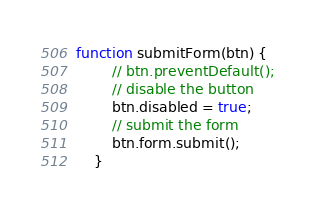Convert code to text. <code><loc_0><loc_0><loc_500><loc_500><_JavaScript_>function submitForm(btn) {
		// btn.preventDefault();
        // disable the button
        btn.disabled = true;
        // submit the form    
        btn.form.submit();
    }</code> 